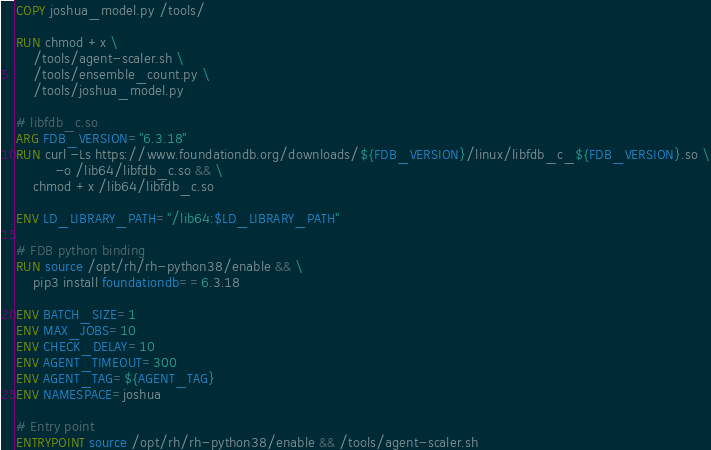Convert code to text. <code><loc_0><loc_0><loc_500><loc_500><_Dockerfile_>COPY joshua_model.py /tools/

RUN chmod +x \
    /tools/agent-scaler.sh \
    /tools/ensemble_count.py \
    /tools/joshua_model.py

# libfdb_c.so
ARG FDB_VERSION="6.3.18"
RUN curl -Ls https://www.foundationdb.org/downloads/${FDB_VERSION}/linux/libfdb_c_${FDB_VERSION}.so \
         -o /lib64/libfdb_c.so && \
    chmod +x /lib64/libfdb_c.so

ENV LD_LIBRARY_PATH="/lib64:$LD_LIBRARY_PATH"

# FDB python binding
RUN source /opt/rh/rh-python38/enable && \
    pip3 install foundationdb==6.3.18

ENV BATCH_SIZE=1
ENV MAX_JOBS=10
ENV CHECK_DELAY=10
ENV AGENT_TIMEOUT=300
ENV AGENT_TAG=${AGENT_TAG}
ENV NAMESPACE=joshua

# Entry point
ENTRYPOINT source /opt/rh/rh-python38/enable && /tools/agent-scaler.sh
</code> 